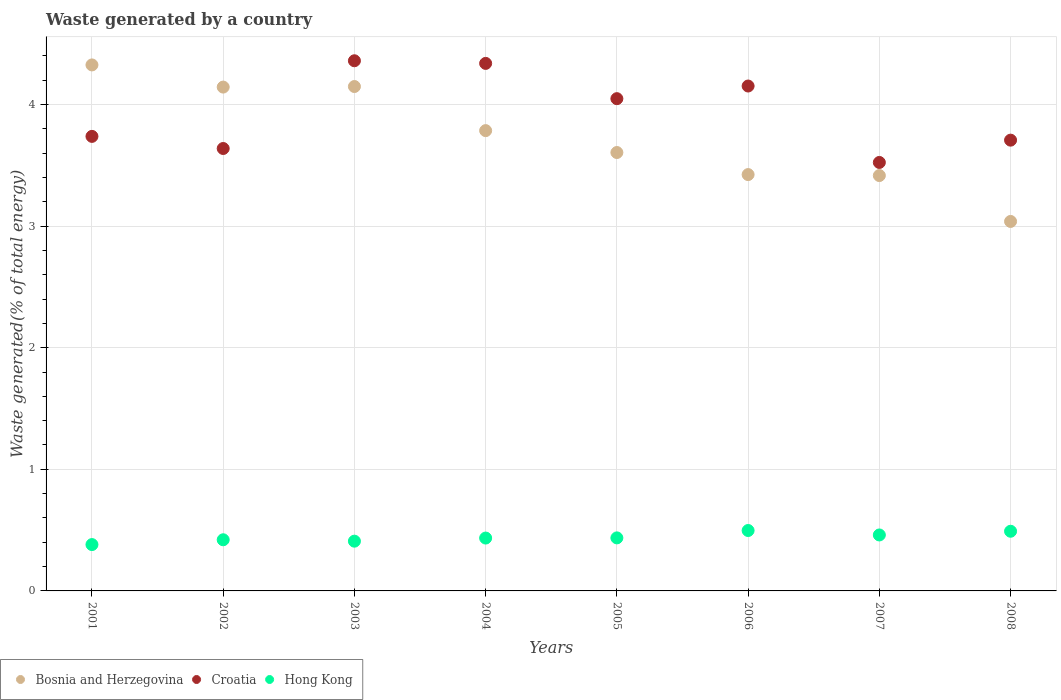How many different coloured dotlines are there?
Provide a short and direct response. 3. Is the number of dotlines equal to the number of legend labels?
Offer a terse response. Yes. What is the total waste generated in Hong Kong in 2001?
Give a very brief answer. 0.38. Across all years, what is the maximum total waste generated in Croatia?
Offer a terse response. 4.36. Across all years, what is the minimum total waste generated in Bosnia and Herzegovina?
Your response must be concise. 3.04. What is the total total waste generated in Bosnia and Herzegovina in the graph?
Ensure brevity in your answer.  29.89. What is the difference between the total waste generated in Hong Kong in 2006 and that in 2007?
Offer a terse response. 0.04. What is the difference between the total waste generated in Hong Kong in 2002 and the total waste generated in Bosnia and Herzegovina in 2005?
Keep it short and to the point. -3.18. What is the average total waste generated in Hong Kong per year?
Offer a very short reply. 0.44. In the year 2006, what is the difference between the total waste generated in Hong Kong and total waste generated in Bosnia and Herzegovina?
Your response must be concise. -2.93. What is the ratio of the total waste generated in Hong Kong in 2002 to that in 2007?
Keep it short and to the point. 0.91. Is the difference between the total waste generated in Hong Kong in 2001 and 2002 greater than the difference between the total waste generated in Bosnia and Herzegovina in 2001 and 2002?
Your answer should be compact. No. What is the difference between the highest and the second highest total waste generated in Hong Kong?
Give a very brief answer. 0.01. What is the difference between the highest and the lowest total waste generated in Croatia?
Your response must be concise. 0.84. Does the total waste generated in Hong Kong monotonically increase over the years?
Offer a terse response. No. Is the total waste generated in Croatia strictly less than the total waste generated in Hong Kong over the years?
Offer a very short reply. No. Are the values on the major ticks of Y-axis written in scientific E-notation?
Make the answer very short. No. Does the graph contain any zero values?
Your answer should be compact. No. Does the graph contain grids?
Provide a short and direct response. Yes. Where does the legend appear in the graph?
Provide a short and direct response. Bottom left. What is the title of the graph?
Keep it short and to the point. Waste generated by a country. Does "Iraq" appear as one of the legend labels in the graph?
Make the answer very short. No. What is the label or title of the Y-axis?
Make the answer very short. Waste generated(% of total energy). What is the Waste generated(% of total energy) in Bosnia and Herzegovina in 2001?
Offer a terse response. 4.33. What is the Waste generated(% of total energy) of Croatia in 2001?
Offer a very short reply. 3.74. What is the Waste generated(% of total energy) of Hong Kong in 2001?
Your answer should be very brief. 0.38. What is the Waste generated(% of total energy) of Bosnia and Herzegovina in 2002?
Give a very brief answer. 4.14. What is the Waste generated(% of total energy) of Croatia in 2002?
Give a very brief answer. 3.64. What is the Waste generated(% of total energy) in Hong Kong in 2002?
Offer a very short reply. 0.42. What is the Waste generated(% of total energy) in Bosnia and Herzegovina in 2003?
Keep it short and to the point. 4.15. What is the Waste generated(% of total energy) of Croatia in 2003?
Your response must be concise. 4.36. What is the Waste generated(% of total energy) in Hong Kong in 2003?
Give a very brief answer. 0.41. What is the Waste generated(% of total energy) of Bosnia and Herzegovina in 2004?
Your response must be concise. 3.79. What is the Waste generated(% of total energy) of Croatia in 2004?
Keep it short and to the point. 4.34. What is the Waste generated(% of total energy) of Hong Kong in 2004?
Offer a very short reply. 0.43. What is the Waste generated(% of total energy) in Bosnia and Herzegovina in 2005?
Your answer should be compact. 3.61. What is the Waste generated(% of total energy) of Croatia in 2005?
Offer a very short reply. 4.05. What is the Waste generated(% of total energy) in Hong Kong in 2005?
Offer a terse response. 0.44. What is the Waste generated(% of total energy) in Bosnia and Herzegovina in 2006?
Keep it short and to the point. 3.42. What is the Waste generated(% of total energy) of Croatia in 2006?
Offer a very short reply. 4.15. What is the Waste generated(% of total energy) in Hong Kong in 2006?
Ensure brevity in your answer.  0.5. What is the Waste generated(% of total energy) in Bosnia and Herzegovina in 2007?
Provide a short and direct response. 3.42. What is the Waste generated(% of total energy) of Croatia in 2007?
Ensure brevity in your answer.  3.52. What is the Waste generated(% of total energy) in Hong Kong in 2007?
Ensure brevity in your answer.  0.46. What is the Waste generated(% of total energy) of Bosnia and Herzegovina in 2008?
Keep it short and to the point. 3.04. What is the Waste generated(% of total energy) in Croatia in 2008?
Your response must be concise. 3.71. What is the Waste generated(% of total energy) in Hong Kong in 2008?
Offer a very short reply. 0.49. Across all years, what is the maximum Waste generated(% of total energy) of Bosnia and Herzegovina?
Offer a very short reply. 4.33. Across all years, what is the maximum Waste generated(% of total energy) of Croatia?
Offer a very short reply. 4.36. Across all years, what is the maximum Waste generated(% of total energy) in Hong Kong?
Provide a succinct answer. 0.5. Across all years, what is the minimum Waste generated(% of total energy) in Bosnia and Herzegovina?
Your response must be concise. 3.04. Across all years, what is the minimum Waste generated(% of total energy) in Croatia?
Provide a short and direct response. 3.52. Across all years, what is the minimum Waste generated(% of total energy) of Hong Kong?
Your answer should be compact. 0.38. What is the total Waste generated(% of total energy) in Bosnia and Herzegovina in the graph?
Keep it short and to the point. 29.89. What is the total Waste generated(% of total energy) of Croatia in the graph?
Provide a succinct answer. 31.5. What is the total Waste generated(% of total energy) in Hong Kong in the graph?
Offer a very short reply. 3.53. What is the difference between the Waste generated(% of total energy) of Bosnia and Herzegovina in 2001 and that in 2002?
Provide a short and direct response. 0.18. What is the difference between the Waste generated(% of total energy) of Croatia in 2001 and that in 2002?
Offer a terse response. 0.1. What is the difference between the Waste generated(% of total energy) of Hong Kong in 2001 and that in 2002?
Give a very brief answer. -0.04. What is the difference between the Waste generated(% of total energy) in Bosnia and Herzegovina in 2001 and that in 2003?
Make the answer very short. 0.18. What is the difference between the Waste generated(% of total energy) in Croatia in 2001 and that in 2003?
Offer a very short reply. -0.62. What is the difference between the Waste generated(% of total energy) in Hong Kong in 2001 and that in 2003?
Offer a very short reply. -0.03. What is the difference between the Waste generated(% of total energy) of Bosnia and Herzegovina in 2001 and that in 2004?
Your answer should be compact. 0.54. What is the difference between the Waste generated(% of total energy) of Croatia in 2001 and that in 2004?
Your answer should be very brief. -0.6. What is the difference between the Waste generated(% of total energy) of Hong Kong in 2001 and that in 2004?
Offer a very short reply. -0.05. What is the difference between the Waste generated(% of total energy) in Bosnia and Herzegovina in 2001 and that in 2005?
Ensure brevity in your answer.  0.72. What is the difference between the Waste generated(% of total energy) in Croatia in 2001 and that in 2005?
Provide a short and direct response. -0.31. What is the difference between the Waste generated(% of total energy) of Hong Kong in 2001 and that in 2005?
Ensure brevity in your answer.  -0.06. What is the difference between the Waste generated(% of total energy) in Bosnia and Herzegovina in 2001 and that in 2006?
Your response must be concise. 0.9. What is the difference between the Waste generated(% of total energy) in Croatia in 2001 and that in 2006?
Your response must be concise. -0.41. What is the difference between the Waste generated(% of total energy) in Hong Kong in 2001 and that in 2006?
Provide a succinct answer. -0.12. What is the difference between the Waste generated(% of total energy) of Bosnia and Herzegovina in 2001 and that in 2007?
Ensure brevity in your answer.  0.91. What is the difference between the Waste generated(% of total energy) of Croatia in 2001 and that in 2007?
Ensure brevity in your answer.  0.21. What is the difference between the Waste generated(% of total energy) in Hong Kong in 2001 and that in 2007?
Ensure brevity in your answer.  -0.08. What is the difference between the Waste generated(% of total energy) in Bosnia and Herzegovina in 2001 and that in 2008?
Your answer should be compact. 1.29. What is the difference between the Waste generated(% of total energy) of Croatia in 2001 and that in 2008?
Provide a succinct answer. 0.03. What is the difference between the Waste generated(% of total energy) of Hong Kong in 2001 and that in 2008?
Offer a terse response. -0.11. What is the difference between the Waste generated(% of total energy) in Bosnia and Herzegovina in 2002 and that in 2003?
Make the answer very short. -0. What is the difference between the Waste generated(% of total energy) of Croatia in 2002 and that in 2003?
Your response must be concise. -0.72. What is the difference between the Waste generated(% of total energy) in Hong Kong in 2002 and that in 2003?
Your answer should be compact. 0.01. What is the difference between the Waste generated(% of total energy) of Bosnia and Herzegovina in 2002 and that in 2004?
Your response must be concise. 0.36. What is the difference between the Waste generated(% of total energy) of Croatia in 2002 and that in 2004?
Give a very brief answer. -0.7. What is the difference between the Waste generated(% of total energy) in Hong Kong in 2002 and that in 2004?
Provide a short and direct response. -0.01. What is the difference between the Waste generated(% of total energy) in Bosnia and Herzegovina in 2002 and that in 2005?
Give a very brief answer. 0.54. What is the difference between the Waste generated(% of total energy) of Croatia in 2002 and that in 2005?
Your answer should be compact. -0.41. What is the difference between the Waste generated(% of total energy) in Hong Kong in 2002 and that in 2005?
Provide a short and direct response. -0.02. What is the difference between the Waste generated(% of total energy) of Bosnia and Herzegovina in 2002 and that in 2006?
Provide a short and direct response. 0.72. What is the difference between the Waste generated(% of total energy) in Croatia in 2002 and that in 2006?
Provide a short and direct response. -0.51. What is the difference between the Waste generated(% of total energy) in Hong Kong in 2002 and that in 2006?
Keep it short and to the point. -0.08. What is the difference between the Waste generated(% of total energy) in Bosnia and Herzegovina in 2002 and that in 2007?
Your response must be concise. 0.73. What is the difference between the Waste generated(% of total energy) of Croatia in 2002 and that in 2007?
Offer a terse response. 0.11. What is the difference between the Waste generated(% of total energy) of Hong Kong in 2002 and that in 2007?
Offer a terse response. -0.04. What is the difference between the Waste generated(% of total energy) in Bosnia and Herzegovina in 2002 and that in 2008?
Your response must be concise. 1.1. What is the difference between the Waste generated(% of total energy) in Croatia in 2002 and that in 2008?
Keep it short and to the point. -0.07. What is the difference between the Waste generated(% of total energy) in Hong Kong in 2002 and that in 2008?
Your answer should be compact. -0.07. What is the difference between the Waste generated(% of total energy) in Bosnia and Herzegovina in 2003 and that in 2004?
Keep it short and to the point. 0.36. What is the difference between the Waste generated(% of total energy) of Croatia in 2003 and that in 2004?
Ensure brevity in your answer.  0.02. What is the difference between the Waste generated(% of total energy) of Hong Kong in 2003 and that in 2004?
Provide a succinct answer. -0.03. What is the difference between the Waste generated(% of total energy) in Bosnia and Herzegovina in 2003 and that in 2005?
Your response must be concise. 0.54. What is the difference between the Waste generated(% of total energy) in Croatia in 2003 and that in 2005?
Your response must be concise. 0.31. What is the difference between the Waste generated(% of total energy) in Hong Kong in 2003 and that in 2005?
Your answer should be very brief. -0.03. What is the difference between the Waste generated(% of total energy) in Bosnia and Herzegovina in 2003 and that in 2006?
Ensure brevity in your answer.  0.72. What is the difference between the Waste generated(% of total energy) of Croatia in 2003 and that in 2006?
Offer a terse response. 0.21. What is the difference between the Waste generated(% of total energy) in Hong Kong in 2003 and that in 2006?
Offer a terse response. -0.09. What is the difference between the Waste generated(% of total energy) in Bosnia and Herzegovina in 2003 and that in 2007?
Your response must be concise. 0.73. What is the difference between the Waste generated(% of total energy) of Croatia in 2003 and that in 2007?
Make the answer very short. 0.84. What is the difference between the Waste generated(% of total energy) in Hong Kong in 2003 and that in 2007?
Offer a very short reply. -0.05. What is the difference between the Waste generated(% of total energy) of Bosnia and Herzegovina in 2003 and that in 2008?
Provide a succinct answer. 1.11. What is the difference between the Waste generated(% of total energy) of Croatia in 2003 and that in 2008?
Give a very brief answer. 0.65. What is the difference between the Waste generated(% of total energy) of Hong Kong in 2003 and that in 2008?
Your answer should be very brief. -0.08. What is the difference between the Waste generated(% of total energy) in Bosnia and Herzegovina in 2004 and that in 2005?
Your answer should be compact. 0.18. What is the difference between the Waste generated(% of total energy) in Croatia in 2004 and that in 2005?
Provide a short and direct response. 0.29. What is the difference between the Waste generated(% of total energy) in Hong Kong in 2004 and that in 2005?
Give a very brief answer. -0. What is the difference between the Waste generated(% of total energy) in Bosnia and Herzegovina in 2004 and that in 2006?
Your response must be concise. 0.36. What is the difference between the Waste generated(% of total energy) of Croatia in 2004 and that in 2006?
Offer a terse response. 0.19. What is the difference between the Waste generated(% of total energy) in Hong Kong in 2004 and that in 2006?
Offer a very short reply. -0.06. What is the difference between the Waste generated(% of total energy) in Bosnia and Herzegovina in 2004 and that in 2007?
Make the answer very short. 0.37. What is the difference between the Waste generated(% of total energy) of Croatia in 2004 and that in 2007?
Give a very brief answer. 0.81. What is the difference between the Waste generated(% of total energy) of Hong Kong in 2004 and that in 2007?
Your answer should be very brief. -0.03. What is the difference between the Waste generated(% of total energy) in Bosnia and Herzegovina in 2004 and that in 2008?
Keep it short and to the point. 0.75. What is the difference between the Waste generated(% of total energy) in Croatia in 2004 and that in 2008?
Your response must be concise. 0.63. What is the difference between the Waste generated(% of total energy) of Hong Kong in 2004 and that in 2008?
Your answer should be very brief. -0.06. What is the difference between the Waste generated(% of total energy) in Bosnia and Herzegovina in 2005 and that in 2006?
Your answer should be very brief. 0.18. What is the difference between the Waste generated(% of total energy) of Croatia in 2005 and that in 2006?
Provide a succinct answer. -0.1. What is the difference between the Waste generated(% of total energy) in Hong Kong in 2005 and that in 2006?
Offer a very short reply. -0.06. What is the difference between the Waste generated(% of total energy) in Bosnia and Herzegovina in 2005 and that in 2007?
Your response must be concise. 0.19. What is the difference between the Waste generated(% of total energy) in Croatia in 2005 and that in 2007?
Your answer should be very brief. 0.52. What is the difference between the Waste generated(% of total energy) in Hong Kong in 2005 and that in 2007?
Give a very brief answer. -0.02. What is the difference between the Waste generated(% of total energy) in Bosnia and Herzegovina in 2005 and that in 2008?
Offer a very short reply. 0.57. What is the difference between the Waste generated(% of total energy) in Croatia in 2005 and that in 2008?
Keep it short and to the point. 0.34. What is the difference between the Waste generated(% of total energy) of Hong Kong in 2005 and that in 2008?
Keep it short and to the point. -0.05. What is the difference between the Waste generated(% of total energy) in Bosnia and Herzegovina in 2006 and that in 2007?
Your response must be concise. 0.01. What is the difference between the Waste generated(% of total energy) of Croatia in 2006 and that in 2007?
Provide a short and direct response. 0.63. What is the difference between the Waste generated(% of total energy) of Hong Kong in 2006 and that in 2007?
Provide a short and direct response. 0.04. What is the difference between the Waste generated(% of total energy) of Bosnia and Herzegovina in 2006 and that in 2008?
Your response must be concise. 0.39. What is the difference between the Waste generated(% of total energy) of Croatia in 2006 and that in 2008?
Make the answer very short. 0.45. What is the difference between the Waste generated(% of total energy) in Hong Kong in 2006 and that in 2008?
Give a very brief answer. 0.01. What is the difference between the Waste generated(% of total energy) in Bosnia and Herzegovina in 2007 and that in 2008?
Your answer should be very brief. 0.38. What is the difference between the Waste generated(% of total energy) in Croatia in 2007 and that in 2008?
Offer a very short reply. -0.18. What is the difference between the Waste generated(% of total energy) of Hong Kong in 2007 and that in 2008?
Offer a very short reply. -0.03. What is the difference between the Waste generated(% of total energy) in Bosnia and Herzegovina in 2001 and the Waste generated(% of total energy) in Croatia in 2002?
Your answer should be compact. 0.69. What is the difference between the Waste generated(% of total energy) in Bosnia and Herzegovina in 2001 and the Waste generated(% of total energy) in Hong Kong in 2002?
Offer a terse response. 3.9. What is the difference between the Waste generated(% of total energy) of Croatia in 2001 and the Waste generated(% of total energy) of Hong Kong in 2002?
Offer a very short reply. 3.32. What is the difference between the Waste generated(% of total energy) in Bosnia and Herzegovina in 2001 and the Waste generated(% of total energy) in Croatia in 2003?
Provide a succinct answer. -0.03. What is the difference between the Waste generated(% of total energy) in Bosnia and Herzegovina in 2001 and the Waste generated(% of total energy) in Hong Kong in 2003?
Offer a terse response. 3.92. What is the difference between the Waste generated(% of total energy) in Croatia in 2001 and the Waste generated(% of total energy) in Hong Kong in 2003?
Your answer should be compact. 3.33. What is the difference between the Waste generated(% of total energy) of Bosnia and Herzegovina in 2001 and the Waste generated(% of total energy) of Croatia in 2004?
Your answer should be compact. -0.01. What is the difference between the Waste generated(% of total energy) in Bosnia and Herzegovina in 2001 and the Waste generated(% of total energy) in Hong Kong in 2004?
Your answer should be very brief. 3.89. What is the difference between the Waste generated(% of total energy) of Croatia in 2001 and the Waste generated(% of total energy) of Hong Kong in 2004?
Your answer should be very brief. 3.3. What is the difference between the Waste generated(% of total energy) of Bosnia and Herzegovina in 2001 and the Waste generated(% of total energy) of Croatia in 2005?
Your answer should be compact. 0.28. What is the difference between the Waste generated(% of total energy) in Bosnia and Herzegovina in 2001 and the Waste generated(% of total energy) in Hong Kong in 2005?
Provide a short and direct response. 3.89. What is the difference between the Waste generated(% of total energy) in Croatia in 2001 and the Waste generated(% of total energy) in Hong Kong in 2005?
Keep it short and to the point. 3.3. What is the difference between the Waste generated(% of total energy) in Bosnia and Herzegovina in 2001 and the Waste generated(% of total energy) in Croatia in 2006?
Your response must be concise. 0.17. What is the difference between the Waste generated(% of total energy) in Bosnia and Herzegovina in 2001 and the Waste generated(% of total energy) in Hong Kong in 2006?
Offer a terse response. 3.83. What is the difference between the Waste generated(% of total energy) of Croatia in 2001 and the Waste generated(% of total energy) of Hong Kong in 2006?
Offer a very short reply. 3.24. What is the difference between the Waste generated(% of total energy) of Bosnia and Herzegovina in 2001 and the Waste generated(% of total energy) of Croatia in 2007?
Offer a terse response. 0.8. What is the difference between the Waste generated(% of total energy) in Bosnia and Herzegovina in 2001 and the Waste generated(% of total energy) in Hong Kong in 2007?
Offer a terse response. 3.87. What is the difference between the Waste generated(% of total energy) in Croatia in 2001 and the Waste generated(% of total energy) in Hong Kong in 2007?
Make the answer very short. 3.28. What is the difference between the Waste generated(% of total energy) in Bosnia and Herzegovina in 2001 and the Waste generated(% of total energy) in Croatia in 2008?
Make the answer very short. 0.62. What is the difference between the Waste generated(% of total energy) of Bosnia and Herzegovina in 2001 and the Waste generated(% of total energy) of Hong Kong in 2008?
Your response must be concise. 3.83. What is the difference between the Waste generated(% of total energy) of Croatia in 2001 and the Waste generated(% of total energy) of Hong Kong in 2008?
Provide a short and direct response. 3.25. What is the difference between the Waste generated(% of total energy) in Bosnia and Herzegovina in 2002 and the Waste generated(% of total energy) in Croatia in 2003?
Keep it short and to the point. -0.22. What is the difference between the Waste generated(% of total energy) of Bosnia and Herzegovina in 2002 and the Waste generated(% of total energy) of Hong Kong in 2003?
Keep it short and to the point. 3.73. What is the difference between the Waste generated(% of total energy) in Croatia in 2002 and the Waste generated(% of total energy) in Hong Kong in 2003?
Ensure brevity in your answer.  3.23. What is the difference between the Waste generated(% of total energy) of Bosnia and Herzegovina in 2002 and the Waste generated(% of total energy) of Croatia in 2004?
Your answer should be very brief. -0.19. What is the difference between the Waste generated(% of total energy) in Bosnia and Herzegovina in 2002 and the Waste generated(% of total energy) in Hong Kong in 2004?
Your response must be concise. 3.71. What is the difference between the Waste generated(% of total energy) of Croatia in 2002 and the Waste generated(% of total energy) of Hong Kong in 2004?
Give a very brief answer. 3.2. What is the difference between the Waste generated(% of total energy) of Bosnia and Herzegovina in 2002 and the Waste generated(% of total energy) of Croatia in 2005?
Ensure brevity in your answer.  0.1. What is the difference between the Waste generated(% of total energy) in Bosnia and Herzegovina in 2002 and the Waste generated(% of total energy) in Hong Kong in 2005?
Your response must be concise. 3.71. What is the difference between the Waste generated(% of total energy) in Croatia in 2002 and the Waste generated(% of total energy) in Hong Kong in 2005?
Your answer should be compact. 3.2. What is the difference between the Waste generated(% of total energy) of Bosnia and Herzegovina in 2002 and the Waste generated(% of total energy) of Croatia in 2006?
Your answer should be compact. -0.01. What is the difference between the Waste generated(% of total energy) in Bosnia and Herzegovina in 2002 and the Waste generated(% of total energy) in Hong Kong in 2006?
Your answer should be very brief. 3.65. What is the difference between the Waste generated(% of total energy) of Croatia in 2002 and the Waste generated(% of total energy) of Hong Kong in 2006?
Your answer should be very brief. 3.14. What is the difference between the Waste generated(% of total energy) in Bosnia and Herzegovina in 2002 and the Waste generated(% of total energy) in Croatia in 2007?
Provide a short and direct response. 0.62. What is the difference between the Waste generated(% of total energy) of Bosnia and Herzegovina in 2002 and the Waste generated(% of total energy) of Hong Kong in 2007?
Your answer should be compact. 3.68. What is the difference between the Waste generated(% of total energy) of Croatia in 2002 and the Waste generated(% of total energy) of Hong Kong in 2007?
Offer a very short reply. 3.18. What is the difference between the Waste generated(% of total energy) in Bosnia and Herzegovina in 2002 and the Waste generated(% of total energy) in Croatia in 2008?
Ensure brevity in your answer.  0.44. What is the difference between the Waste generated(% of total energy) of Bosnia and Herzegovina in 2002 and the Waste generated(% of total energy) of Hong Kong in 2008?
Make the answer very short. 3.65. What is the difference between the Waste generated(% of total energy) of Croatia in 2002 and the Waste generated(% of total energy) of Hong Kong in 2008?
Keep it short and to the point. 3.15. What is the difference between the Waste generated(% of total energy) of Bosnia and Herzegovina in 2003 and the Waste generated(% of total energy) of Croatia in 2004?
Provide a succinct answer. -0.19. What is the difference between the Waste generated(% of total energy) in Bosnia and Herzegovina in 2003 and the Waste generated(% of total energy) in Hong Kong in 2004?
Your response must be concise. 3.71. What is the difference between the Waste generated(% of total energy) in Croatia in 2003 and the Waste generated(% of total energy) in Hong Kong in 2004?
Provide a short and direct response. 3.92. What is the difference between the Waste generated(% of total energy) in Bosnia and Herzegovina in 2003 and the Waste generated(% of total energy) in Croatia in 2005?
Your response must be concise. 0.1. What is the difference between the Waste generated(% of total energy) of Bosnia and Herzegovina in 2003 and the Waste generated(% of total energy) of Hong Kong in 2005?
Your response must be concise. 3.71. What is the difference between the Waste generated(% of total energy) of Croatia in 2003 and the Waste generated(% of total energy) of Hong Kong in 2005?
Your answer should be compact. 3.92. What is the difference between the Waste generated(% of total energy) in Bosnia and Herzegovina in 2003 and the Waste generated(% of total energy) in Croatia in 2006?
Make the answer very short. -0. What is the difference between the Waste generated(% of total energy) in Bosnia and Herzegovina in 2003 and the Waste generated(% of total energy) in Hong Kong in 2006?
Your answer should be very brief. 3.65. What is the difference between the Waste generated(% of total energy) in Croatia in 2003 and the Waste generated(% of total energy) in Hong Kong in 2006?
Give a very brief answer. 3.86. What is the difference between the Waste generated(% of total energy) of Bosnia and Herzegovina in 2003 and the Waste generated(% of total energy) of Croatia in 2007?
Offer a very short reply. 0.62. What is the difference between the Waste generated(% of total energy) of Bosnia and Herzegovina in 2003 and the Waste generated(% of total energy) of Hong Kong in 2007?
Your response must be concise. 3.69. What is the difference between the Waste generated(% of total energy) of Croatia in 2003 and the Waste generated(% of total energy) of Hong Kong in 2007?
Offer a terse response. 3.9. What is the difference between the Waste generated(% of total energy) of Bosnia and Herzegovina in 2003 and the Waste generated(% of total energy) of Croatia in 2008?
Provide a succinct answer. 0.44. What is the difference between the Waste generated(% of total energy) in Bosnia and Herzegovina in 2003 and the Waste generated(% of total energy) in Hong Kong in 2008?
Keep it short and to the point. 3.66. What is the difference between the Waste generated(% of total energy) in Croatia in 2003 and the Waste generated(% of total energy) in Hong Kong in 2008?
Ensure brevity in your answer.  3.87. What is the difference between the Waste generated(% of total energy) of Bosnia and Herzegovina in 2004 and the Waste generated(% of total energy) of Croatia in 2005?
Make the answer very short. -0.26. What is the difference between the Waste generated(% of total energy) in Bosnia and Herzegovina in 2004 and the Waste generated(% of total energy) in Hong Kong in 2005?
Offer a terse response. 3.35. What is the difference between the Waste generated(% of total energy) in Croatia in 2004 and the Waste generated(% of total energy) in Hong Kong in 2005?
Your answer should be very brief. 3.9. What is the difference between the Waste generated(% of total energy) of Bosnia and Herzegovina in 2004 and the Waste generated(% of total energy) of Croatia in 2006?
Give a very brief answer. -0.37. What is the difference between the Waste generated(% of total energy) in Bosnia and Herzegovina in 2004 and the Waste generated(% of total energy) in Hong Kong in 2006?
Offer a terse response. 3.29. What is the difference between the Waste generated(% of total energy) in Croatia in 2004 and the Waste generated(% of total energy) in Hong Kong in 2006?
Provide a succinct answer. 3.84. What is the difference between the Waste generated(% of total energy) in Bosnia and Herzegovina in 2004 and the Waste generated(% of total energy) in Croatia in 2007?
Offer a terse response. 0.26. What is the difference between the Waste generated(% of total energy) in Bosnia and Herzegovina in 2004 and the Waste generated(% of total energy) in Hong Kong in 2007?
Give a very brief answer. 3.33. What is the difference between the Waste generated(% of total energy) of Croatia in 2004 and the Waste generated(% of total energy) of Hong Kong in 2007?
Ensure brevity in your answer.  3.88. What is the difference between the Waste generated(% of total energy) in Bosnia and Herzegovina in 2004 and the Waste generated(% of total energy) in Croatia in 2008?
Make the answer very short. 0.08. What is the difference between the Waste generated(% of total energy) in Bosnia and Herzegovina in 2004 and the Waste generated(% of total energy) in Hong Kong in 2008?
Make the answer very short. 3.29. What is the difference between the Waste generated(% of total energy) in Croatia in 2004 and the Waste generated(% of total energy) in Hong Kong in 2008?
Provide a short and direct response. 3.85. What is the difference between the Waste generated(% of total energy) in Bosnia and Herzegovina in 2005 and the Waste generated(% of total energy) in Croatia in 2006?
Ensure brevity in your answer.  -0.55. What is the difference between the Waste generated(% of total energy) of Bosnia and Herzegovina in 2005 and the Waste generated(% of total energy) of Hong Kong in 2006?
Provide a short and direct response. 3.11. What is the difference between the Waste generated(% of total energy) in Croatia in 2005 and the Waste generated(% of total energy) in Hong Kong in 2006?
Ensure brevity in your answer.  3.55. What is the difference between the Waste generated(% of total energy) of Bosnia and Herzegovina in 2005 and the Waste generated(% of total energy) of Croatia in 2007?
Ensure brevity in your answer.  0.08. What is the difference between the Waste generated(% of total energy) of Bosnia and Herzegovina in 2005 and the Waste generated(% of total energy) of Hong Kong in 2007?
Make the answer very short. 3.15. What is the difference between the Waste generated(% of total energy) of Croatia in 2005 and the Waste generated(% of total energy) of Hong Kong in 2007?
Offer a terse response. 3.59. What is the difference between the Waste generated(% of total energy) of Bosnia and Herzegovina in 2005 and the Waste generated(% of total energy) of Croatia in 2008?
Give a very brief answer. -0.1. What is the difference between the Waste generated(% of total energy) in Bosnia and Herzegovina in 2005 and the Waste generated(% of total energy) in Hong Kong in 2008?
Provide a short and direct response. 3.11. What is the difference between the Waste generated(% of total energy) in Croatia in 2005 and the Waste generated(% of total energy) in Hong Kong in 2008?
Ensure brevity in your answer.  3.56. What is the difference between the Waste generated(% of total energy) in Bosnia and Herzegovina in 2006 and the Waste generated(% of total energy) in Croatia in 2007?
Offer a terse response. -0.1. What is the difference between the Waste generated(% of total energy) in Bosnia and Herzegovina in 2006 and the Waste generated(% of total energy) in Hong Kong in 2007?
Your answer should be very brief. 2.96. What is the difference between the Waste generated(% of total energy) of Croatia in 2006 and the Waste generated(% of total energy) of Hong Kong in 2007?
Your answer should be very brief. 3.69. What is the difference between the Waste generated(% of total energy) in Bosnia and Herzegovina in 2006 and the Waste generated(% of total energy) in Croatia in 2008?
Your answer should be compact. -0.28. What is the difference between the Waste generated(% of total energy) in Bosnia and Herzegovina in 2006 and the Waste generated(% of total energy) in Hong Kong in 2008?
Your response must be concise. 2.93. What is the difference between the Waste generated(% of total energy) of Croatia in 2006 and the Waste generated(% of total energy) of Hong Kong in 2008?
Offer a very short reply. 3.66. What is the difference between the Waste generated(% of total energy) of Bosnia and Herzegovina in 2007 and the Waste generated(% of total energy) of Croatia in 2008?
Your answer should be compact. -0.29. What is the difference between the Waste generated(% of total energy) in Bosnia and Herzegovina in 2007 and the Waste generated(% of total energy) in Hong Kong in 2008?
Your answer should be compact. 2.93. What is the difference between the Waste generated(% of total energy) of Croatia in 2007 and the Waste generated(% of total energy) of Hong Kong in 2008?
Keep it short and to the point. 3.03. What is the average Waste generated(% of total energy) of Bosnia and Herzegovina per year?
Your response must be concise. 3.74. What is the average Waste generated(% of total energy) in Croatia per year?
Offer a terse response. 3.94. What is the average Waste generated(% of total energy) of Hong Kong per year?
Your response must be concise. 0.44. In the year 2001, what is the difference between the Waste generated(% of total energy) in Bosnia and Herzegovina and Waste generated(% of total energy) in Croatia?
Make the answer very short. 0.59. In the year 2001, what is the difference between the Waste generated(% of total energy) in Bosnia and Herzegovina and Waste generated(% of total energy) in Hong Kong?
Ensure brevity in your answer.  3.94. In the year 2001, what is the difference between the Waste generated(% of total energy) of Croatia and Waste generated(% of total energy) of Hong Kong?
Your answer should be compact. 3.36. In the year 2002, what is the difference between the Waste generated(% of total energy) in Bosnia and Herzegovina and Waste generated(% of total energy) in Croatia?
Provide a short and direct response. 0.51. In the year 2002, what is the difference between the Waste generated(% of total energy) in Bosnia and Herzegovina and Waste generated(% of total energy) in Hong Kong?
Your answer should be compact. 3.72. In the year 2002, what is the difference between the Waste generated(% of total energy) of Croatia and Waste generated(% of total energy) of Hong Kong?
Your answer should be compact. 3.22. In the year 2003, what is the difference between the Waste generated(% of total energy) of Bosnia and Herzegovina and Waste generated(% of total energy) of Croatia?
Your response must be concise. -0.21. In the year 2003, what is the difference between the Waste generated(% of total energy) in Bosnia and Herzegovina and Waste generated(% of total energy) in Hong Kong?
Your answer should be very brief. 3.74. In the year 2003, what is the difference between the Waste generated(% of total energy) of Croatia and Waste generated(% of total energy) of Hong Kong?
Provide a short and direct response. 3.95. In the year 2004, what is the difference between the Waste generated(% of total energy) of Bosnia and Herzegovina and Waste generated(% of total energy) of Croatia?
Offer a terse response. -0.55. In the year 2004, what is the difference between the Waste generated(% of total energy) in Bosnia and Herzegovina and Waste generated(% of total energy) in Hong Kong?
Offer a terse response. 3.35. In the year 2004, what is the difference between the Waste generated(% of total energy) of Croatia and Waste generated(% of total energy) of Hong Kong?
Your answer should be compact. 3.9. In the year 2005, what is the difference between the Waste generated(% of total energy) in Bosnia and Herzegovina and Waste generated(% of total energy) in Croatia?
Your answer should be compact. -0.44. In the year 2005, what is the difference between the Waste generated(% of total energy) of Bosnia and Herzegovina and Waste generated(% of total energy) of Hong Kong?
Your answer should be very brief. 3.17. In the year 2005, what is the difference between the Waste generated(% of total energy) in Croatia and Waste generated(% of total energy) in Hong Kong?
Keep it short and to the point. 3.61. In the year 2006, what is the difference between the Waste generated(% of total energy) of Bosnia and Herzegovina and Waste generated(% of total energy) of Croatia?
Keep it short and to the point. -0.73. In the year 2006, what is the difference between the Waste generated(% of total energy) of Bosnia and Herzegovina and Waste generated(% of total energy) of Hong Kong?
Make the answer very short. 2.93. In the year 2006, what is the difference between the Waste generated(% of total energy) of Croatia and Waste generated(% of total energy) of Hong Kong?
Your response must be concise. 3.66. In the year 2007, what is the difference between the Waste generated(% of total energy) in Bosnia and Herzegovina and Waste generated(% of total energy) in Croatia?
Ensure brevity in your answer.  -0.11. In the year 2007, what is the difference between the Waste generated(% of total energy) in Bosnia and Herzegovina and Waste generated(% of total energy) in Hong Kong?
Provide a short and direct response. 2.96. In the year 2007, what is the difference between the Waste generated(% of total energy) of Croatia and Waste generated(% of total energy) of Hong Kong?
Offer a terse response. 3.06. In the year 2008, what is the difference between the Waste generated(% of total energy) in Bosnia and Herzegovina and Waste generated(% of total energy) in Croatia?
Offer a very short reply. -0.67. In the year 2008, what is the difference between the Waste generated(% of total energy) of Bosnia and Herzegovina and Waste generated(% of total energy) of Hong Kong?
Offer a very short reply. 2.55. In the year 2008, what is the difference between the Waste generated(% of total energy) in Croatia and Waste generated(% of total energy) in Hong Kong?
Offer a very short reply. 3.22. What is the ratio of the Waste generated(% of total energy) in Bosnia and Herzegovina in 2001 to that in 2002?
Offer a terse response. 1.04. What is the ratio of the Waste generated(% of total energy) of Croatia in 2001 to that in 2002?
Offer a very short reply. 1.03. What is the ratio of the Waste generated(% of total energy) in Hong Kong in 2001 to that in 2002?
Give a very brief answer. 0.91. What is the ratio of the Waste generated(% of total energy) of Bosnia and Herzegovina in 2001 to that in 2003?
Your answer should be compact. 1.04. What is the ratio of the Waste generated(% of total energy) of Croatia in 2001 to that in 2003?
Your answer should be compact. 0.86. What is the ratio of the Waste generated(% of total energy) of Hong Kong in 2001 to that in 2003?
Ensure brevity in your answer.  0.93. What is the ratio of the Waste generated(% of total energy) in Bosnia and Herzegovina in 2001 to that in 2004?
Give a very brief answer. 1.14. What is the ratio of the Waste generated(% of total energy) in Croatia in 2001 to that in 2004?
Offer a terse response. 0.86. What is the ratio of the Waste generated(% of total energy) in Hong Kong in 2001 to that in 2004?
Give a very brief answer. 0.88. What is the ratio of the Waste generated(% of total energy) of Bosnia and Herzegovina in 2001 to that in 2005?
Your answer should be compact. 1.2. What is the ratio of the Waste generated(% of total energy) of Croatia in 2001 to that in 2005?
Your response must be concise. 0.92. What is the ratio of the Waste generated(% of total energy) of Hong Kong in 2001 to that in 2005?
Your answer should be compact. 0.87. What is the ratio of the Waste generated(% of total energy) of Bosnia and Herzegovina in 2001 to that in 2006?
Ensure brevity in your answer.  1.26. What is the ratio of the Waste generated(% of total energy) of Croatia in 2001 to that in 2006?
Make the answer very short. 0.9. What is the ratio of the Waste generated(% of total energy) of Hong Kong in 2001 to that in 2006?
Keep it short and to the point. 0.77. What is the ratio of the Waste generated(% of total energy) in Bosnia and Herzegovina in 2001 to that in 2007?
Give a very brief answer. 1.27. What is the ratio of the Waste generated(% of total energy) in Croatia in 2001 to that in 2007?
Your response must be concise. 1.06. What is the ratio of the Waste generated(% of total energy) in Hong Kong in 2001 to that in 2007?
Provide a succinct answer. 0.83. What is the ratio of the Waste generated(% of total energy) of Bosnia and Herzegovina in 2001 to that in 2008?
Your answer should be very brief. 1.42. What is the ratio of the Waste generated(% of total energy) of Croatia in 2001 to that in 2008?
Provide a succinct answer. 1.01. What is the ratio of the Waste generated(% of total energy) of Hong Kong in 2001 to that in 2008?
Your response must be concise. 0.78. What is the ratio of the Waste generated(% of total energy) of Croatia in 2002 to that in 2003?
Your answer should be very brief. 0.83. What is the ratio of the Waste generated(% of total energy) in Hong Kong in 2002 to that in 2003?
Keep it short and to the point. 1.03. What is the ratio of the Waste generated(% of total energy) of Bosnia and Herzegovina in 2002 to that in 2004?
Offer a very short reply. 1.09. What is the ratio of the Waste generated(% of total energy) of Croatia in 2002 to that in 2004?
Give a very brief answer. 0.84. What is the ratio of the Waste generated(% of total energy) of Hong Kong in 2002 to that in 2004?
Provide a succinct answer. 0.97. What is the ratio of the Waste generated(% of total energy) of Bosnia and Herzegovina in 2002 to that in 2005?
Your response must be concise. 1.15. What is the ratio of the Waste generated(% of total energy) in Croatia in 2002 to that in 2005?
Provide a succinct answer. 0.9. What is the ratio of the Waste generated(% of total energy) of Hong Kong in 2002 to that in 2005?
Offer a very short reply. 0.96. What is the ratio of the Waste generated(% of total energy) of Bosnia and Herzegovina in 2002 to that in 2006?
Your answer should be compact. 1.21. What is the ratio of the Waste generated(% of total energy) in Croatia in 2002 to that in 2006?
Give a very brief answer. 0.88. What is the ratio of the Waste generated(% of total energy) in Hong Kong in 2002 to that in 2006?
Give a very brief answer. 0.85. What is the ratio of the Waste generated(% of total energy) in Bosnia and Herzegovina in 2002 to that in 2007?
Ensure brevity in your answer.  1.21. What is the ratio of the Waste generated(% of total energy) of Croatia in 2002 to that in 2007?
Provide a succinct answer. 1.03. What is the ratio of the Waste generated(% of total energy) in Hong Kong in 2002 to that in 2007?
Make the answer very short. 0.91. What is the ratio of the Waste generated(% of total energy) in Bosnia and Herzegovina in 2002 to that in 2008?
Make the answer very short. 1.36. What is the ratio of the Waste generated(% of total energy) in Croatia in 2002 to that in 2008?
Your answer should be very brief. 0.98. What is the ratio of the Waste generated(% of total energy) in Hong Kong in 2002 to that in 2008?
Offer a very short reply. 0.86. What is the ratio of the Waste generated(% of total energy) in Bosnia and Herzegovina in 2003 to that in 2004?
Provide a short and direct response. 1.1. What is the ratio of the Waste generated(% of total energy) of Croatia in 2003 to that in 2004?
Give a very brief answer. 1. What is the ratio of the Waste generated(% of total energy) in Hong Kong in 2003 to that in 2004?
Your response must be concise. 0.94. What is the ratio of the Waste generated(% of total energy) of Bosnia and Herzegovina in 2003 to that in 2005?
Offer a very short reply. 1.15. What is the ratio of the Waste generated(% of total energy) in Croatia in 2003 to that in 2005?
Ensure brevity in your answer.  1.08. What is the ratio of the Waste generated(% of total energy) of Hong Kong in 2003 to that in 2005?
Keep it short and to the point. 0.94. What is the ratio of the Waste generated(% of total energy) in Bosnia and Herzegovina in 2003 to that in 2006?
Your answer should be compact. 1.21. What is the ratio of the Waste generated(% of total energy) of Hong Kong in 2003 to that in 2006?
Provide a short and direct response. 0.82. What is the ratio of the Waste generated(% of total energy) in Bosnia and Herzegovina in 2003 to that in 2007?
Give a very brief answer. 1.21. What is the ratio of the Waste generated(% of total energy) in Croatia in 2003 to that in 2007?
Your answer should be compact. 1.24. What is the ratio of the Waste generated(% of total energy) of Hong Kong in 2003 to that in 2007?
Offer a very short reply. 0.89. What is the ratio of the Waste generated(% of total energy) of Bosnia and Herzegovina in 2003 to that in 2008?
Your answer should be very brief. 1.37. What is the ratio of the Waste generated(% of total energy) in Croatia in 2003 to that in 2008?
Provide a succinct answer. 1.18. What is the ratio of the Waste generated(% of total energy) in Hong Kong in 2003 to that in 2008?
Provide a succinct answer. 0.83. What is the ratio of the Waste generated(% of total energy) of Bosnia and Herzegovina in 2004 to that in 2005?
Make the answer very short. 1.05. What is the ratio of the Waste generated(% of total energy) of Croatia in 2004 to that in 2005?
Offer a terse response. 1.07. What is the ratio of the Waste generated(% of total energy) in Hong Kong in 2004 to that in 2005?
Give a very brief answer. 1. What is the ratio of the Waste generated(% of total energy) of Bosnia and Herzegovina in 2004 to that in 2006?
Provide a short and direct response. 1.11. What is the ratio of the Waste generated(% of total energy) in Croatia in 2004 to that in 2006?
Provide a succinct answer. 1.04. What is the ratio of the Waste generated(% of total energy) of Hong Kong in 2004 to that in 2006?
Keep it short and to the point. 0.88. What is the ratio of the Waste generated(% of total energy) of Bosnia and Herzegovina in 2004 to that in 2007?
Your response must be concise. 1.11. What is the ratio of the Waste generated(% of total energy) of Croatia in 2004 to that in 2007?
Your answer should be compact. 1.23. What is the ratio of the Waste generated(% of total energy) of Hong Kong in 2004 to that in 2007?
Offer a terse response. 0.94. What is the ratio of the Waste generated(% of total energy) in Bosnia and Herzegovina in 2004 to that in 2008?
Offer a very short reply. 1.25. What is the ratio of the Waste generated(% of total energy) of Croatia in 2004 to that in 2008?
Offer a terse response. 1.17. What is the ratio of the Waste generated(% of total energy) of Hong Kong in 2004 to that in 2008?
Your response must be concise. 0.89. What is the ratio of the Waste generated(% of total energy) in Bosnia and Herzegovina in 2005 to that in 2006?
Offer a terse response. 1.05. What is the ratio of the Waste generated(% of total energy) in Hong Kong in 2005 to that in 2006?
Your answer should be very brief. 0.88. What is the ratio of the Waste generated(% of total energy) in Bosnia and Herzegovina in 2005 to that in 2007?
Keep it short and to the point. 1.06. What is the ratio of the Waste generated(% of total energy) in Croatia in 2005 to that in 2007?
Your answer should be very brief. 1.15. What is the ratio of the Waste generated(% of total energy) of Hong Kong in 2005 to that in 2007?
Offer a terse response. 0.95. What is the ratio of the Waste generated(% of total energy) in Bosnia and Herzegovina in 2005 to that in 2008?
Keep it short and to the point. 1.19. What is the ratio of the Waste generated(% of total energy) in Croatia in 2005 to that in 2008?
Provide a short and direct response. 1.09. What is the ratio of the Waste generated(% of total energy) of Hong Kong in 2005 to that in 2008?
Keep it short and to the point. 0.89. What is the ratio of the Waste generated(% of total energy) of Bosnia and Herzegovina in 2006 to that in 2007?
Provide a short and direct response. 1. What is the ratio of the Waste generated(% of total energy) in Croatia in 2006 to that in 2007?
Keep it short and to the point. 1.18. What is the ratio of the Waste generated(% of total energy) of Hong Kong in 2006 to that in 2007?
Give a very brief answer. 1.08. What is the ratio of the Waste generated(% of total energy) of Bosnia and Herzegovina in 2006 to that in 2008?
Your response must be concise. 1.13. What is the ratio of the Waste generated(% of total energy) in Croatia in 2006 to that in 2008?
Offer a very short reply. 1.12. What is the ratio of the Waste generated(% of total energy) of Hong Kong in 2006 to that in 2008?
Keep it short and to the point. 1.01. What is the ratio of the Waste generated(% of total energy) of Bosnia and Herzegovina in 2007 to that in 2008?
Ensure brevity in your answer.  1.12. What is the ratio of the Waste generated(% of total energy) of Croatia in 2007 to that in 2008?
Give a very brief answer. 0.95. What is the ratio of the Waste generated(% of total energy) of Hong Kong in 2007 to that in 2008?
Offer a terse response. 0.94. What is the difference between the highest and the second highest Waste generated(% of total energy) of Bosnia and Herzegovina?
Offer a very short reply. 0.18. What is the difference between the highest and the second highest Waste generated(% of total energy) in Croatia?
Offer a terse response. 0.02. What is the difference between the highest and the second highest Waste generated(% of total energy) of Hong Kong?
Offer a terse response. 0.01. What is the difference between the highest and the lowest Waste generated(% of total energy) of Bosnia and Herzegovina?
Your response must be concise. 1.29. What is the difference between the highest and the lowest Waste generated(% of total energy) in Croatia?
Offer a terse response. 0.84. What is the difference between the highest and the lowest Waste generated(% of total energy) in Hong Kong?
Offer a very short reply. 0.12. 